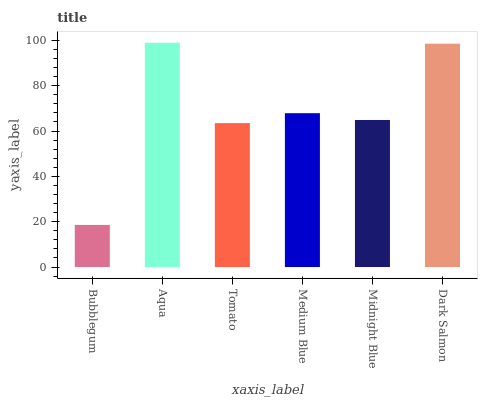Is Bubblegum the minimum?
Answer yes or no. Yes. Is Aqua the maximum?
Answer yes or no. Yes. Is Tomato the minimum?
Answer yes or no. No. Is Tomato the maximum?
Answer yes or no. No. Is Aqua greater than Tomato?
Answer yes or no. Yes. Is Tomato less than Aqua?
Answer yes or no. Yes. Is Tomato greater than Aqua?
Answer yes or no. No. Is Aqua less than Tomato?
Answer yes or no. No. Is Medium Blue the high median?
Answer yes or no. Yes. Is Midnight Blue the low median?
Answer yes or no. Yes. Is Midnight Blue the high median?
Answer yes or no. No. Is Medium Blue the low median?
Answer yes or no. No. 